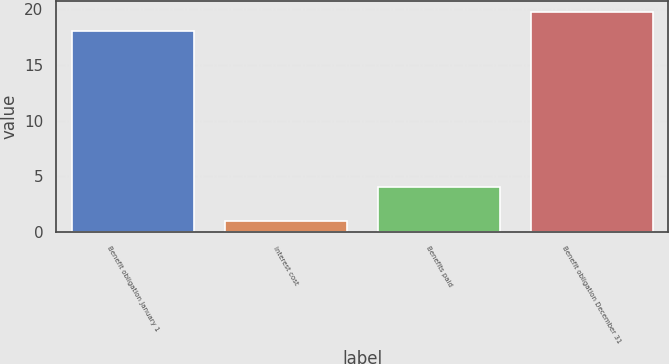Convert chart. <chart><loc_0><loc_0><loc_500><loc_500><bar_chart><fcel>Benefit obligation January 1<fcel>Interest cost<fcel>Benefits paid<fcel>Benefit obligation December 31<nl><fcel>18<fcel>1<fcel>4<fcel>19.7<nl></chart> 